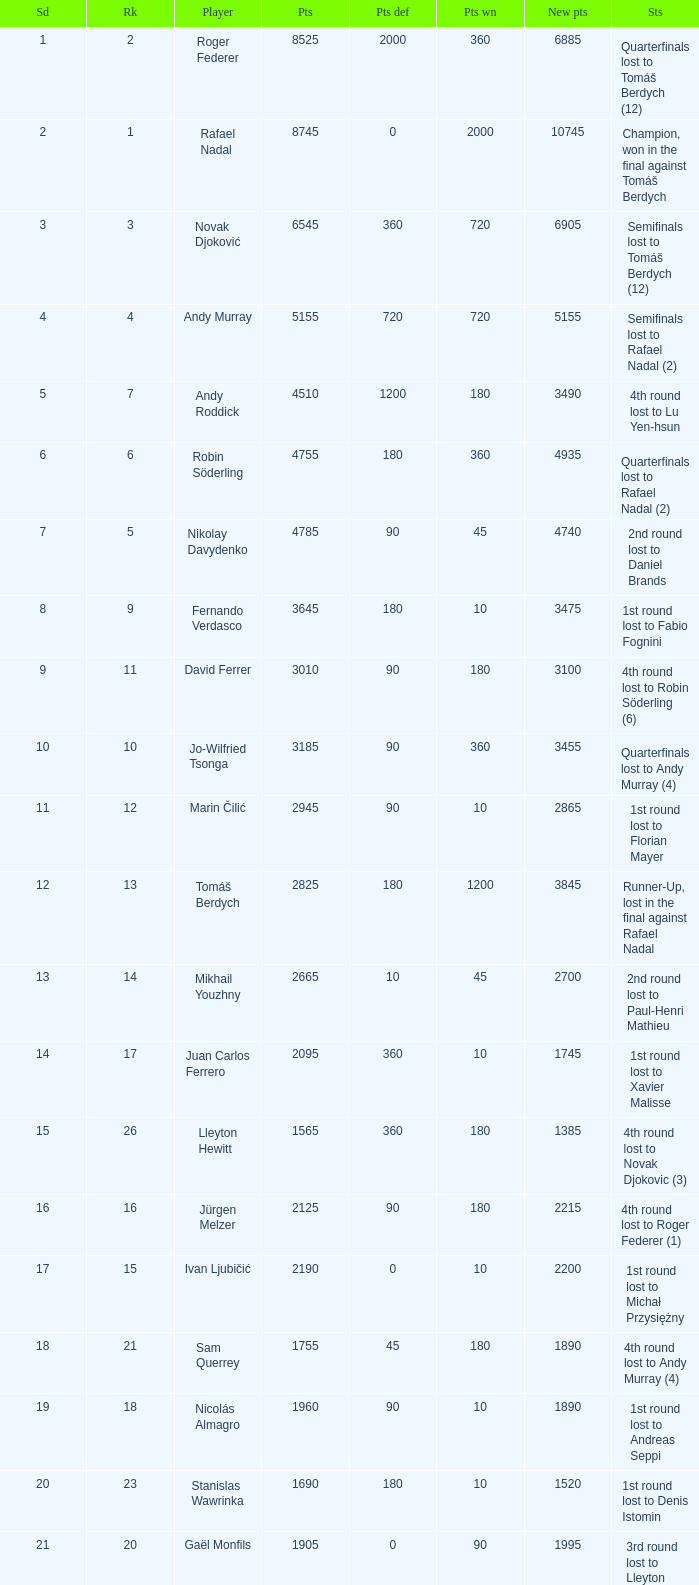Name the status for points 3185 Quarterfinals lost to Andy Murray (4). 